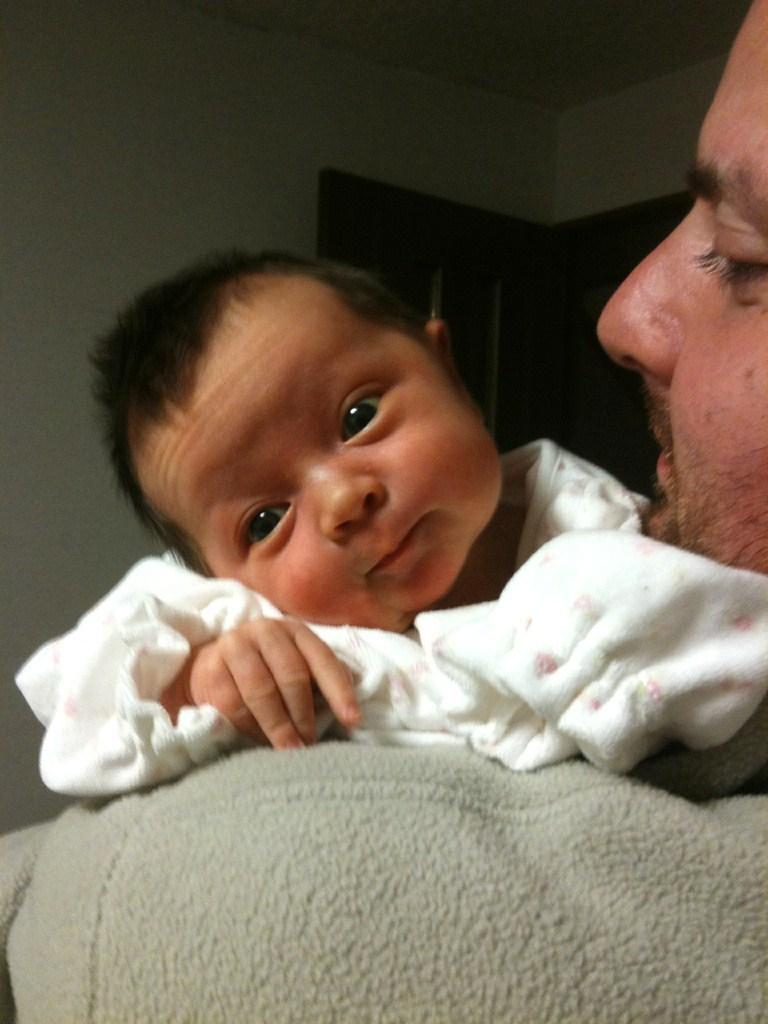Who is the main subject in the image? There is a man in the image. What is the man doing in the image? The man is holding a small kid. What is the kid wearing in the image? The kid is wearing a white dress. What is the man wearing in the image? The man is wearing a gray sweater. What can be seen in the background of the image? There is a wall and a door in the background of the image. What year is depicted in the image? The image does not depict a specific year; it is a photograph of a man holding a kid. Who is the representative of the group in the image? There is no group or representative mentioned in the image; it simply shows a man holding a kid. 